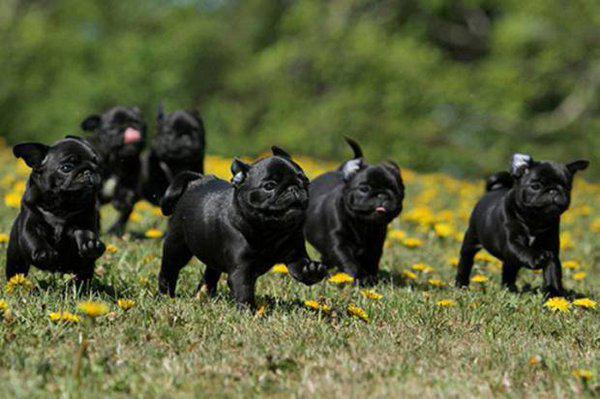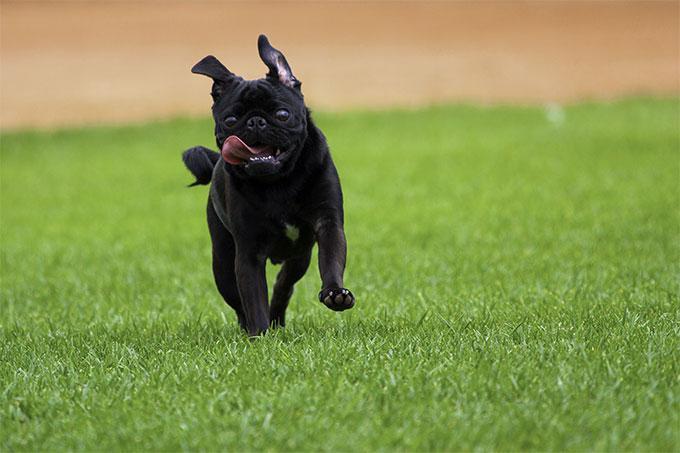The first image is the image on the left, the second image is the image on the right. For the images shown, is this caption "There is at least one black pug running through the grass." true? Answer yes or no. Yes. The first image is the image on the left, the second image is the image on the right. Examine the images to the left and right. Is the description "A white/beige colored pug has been caught on camera with his tongue out." accurate? Answer yes or no. No. 